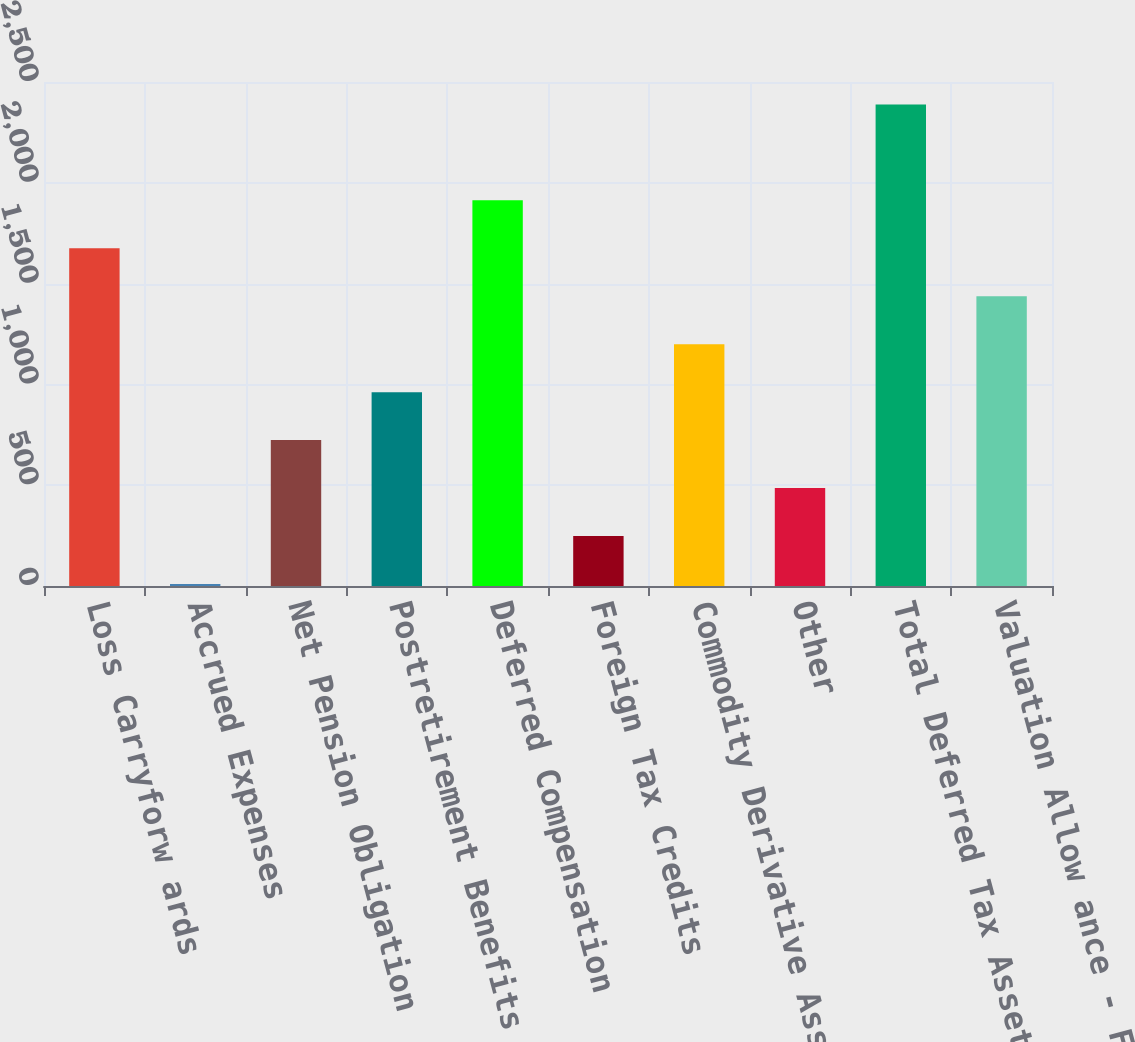<chart> <loc_0><loc_0><loc_500><loc_500><bar_chart><fcel>Loss Carryforw ards<fcel>Accrued Expenses<fcel>Net Pension Obligation<fcel>Postretirement Benefits<fcel>Deferred Compensation<fcel>Foreign Tax Credits<fcel>Commodity Derivative Assets<fcel>Other<fcel>Total Deferred Tax Assets<fcel>Valuation Allow ance - Foreign<nl><fcel>1675.3<fcel>10<fcel>723.7<fcel>961.6<fcel>1913.2<fcel>247.9<fcel>1199.5<fcel>485.8<fcel>2389<fcel>1437.4<nl></chart> 